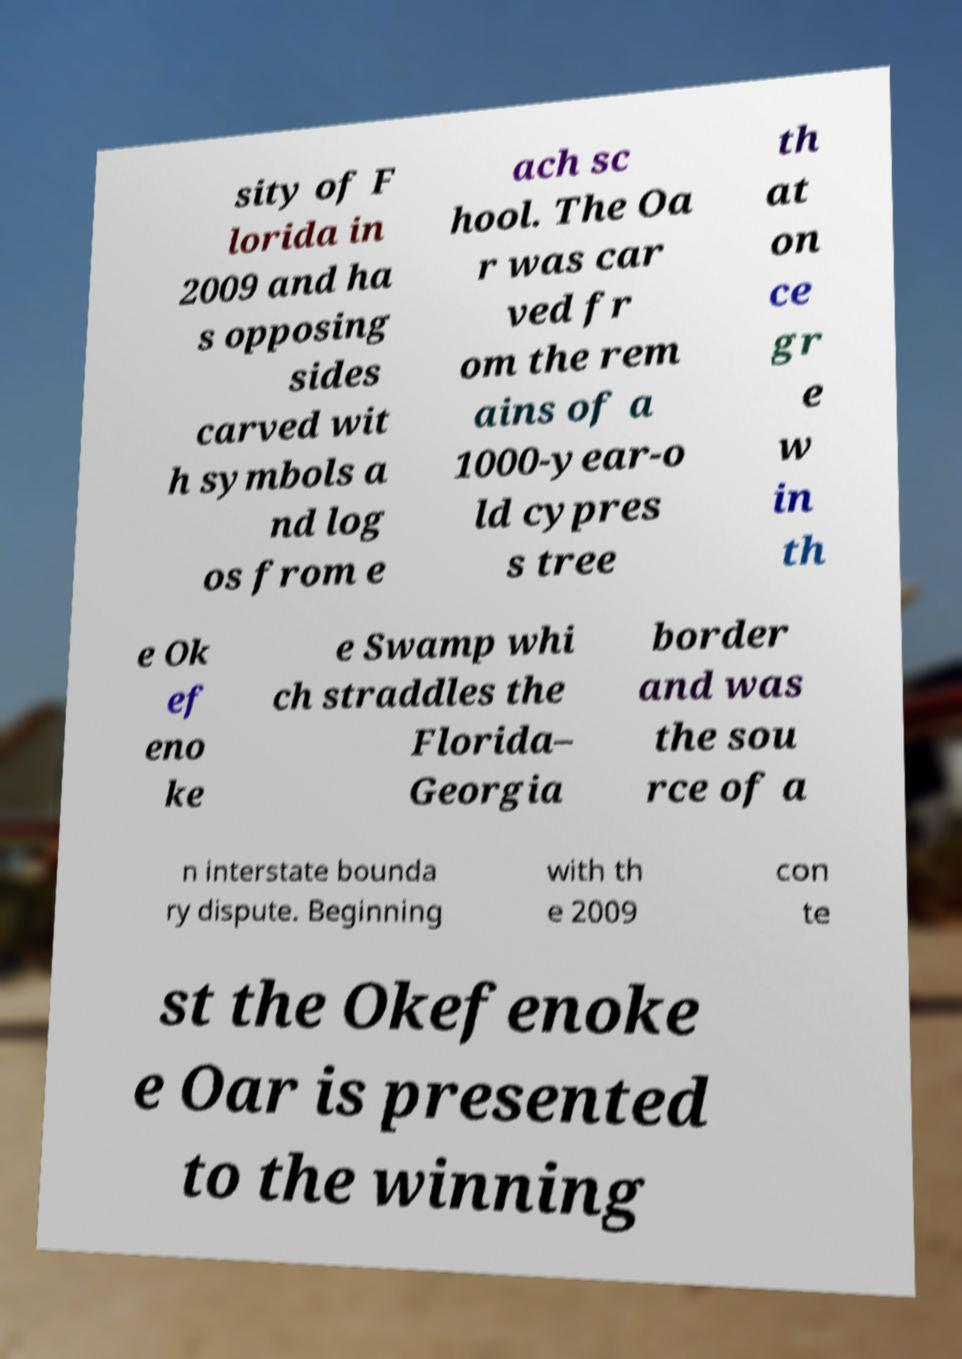Please identify and transcribe the text found in this image. sity of F lorida in 2009 and ha s opposing sides carved wit h symbols a nd log os from e ach sc hool. The Oa r was car ved fr om the rem ains of a 1000-year-o ld cypres s tree th at on ce gr e w in th e Ok ef eno ke e Swamp whi ch straddles the Florida– Georgia border and was the sou rce of a n interstate bounda ry dispute. Beginning with th e 2009 con te st the Okefenoke e Oar is presented to the winning 